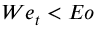<formula> <loc_0><loc_0><loc_500><loc_500>W e _ { t } < E o</formula> 